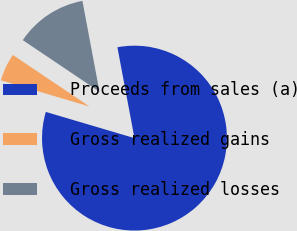Convert chart to OTSL. <chart><loc_0><loc_0><loc_500><loc_500><pie_chart><fcel>Proceeds from sales (a)<fcel>Gross realized gains<fcel>Gross realized losses<nl><fcel>82.52%<fcel>4.85%<fcel>12.62%<nl></chart> 